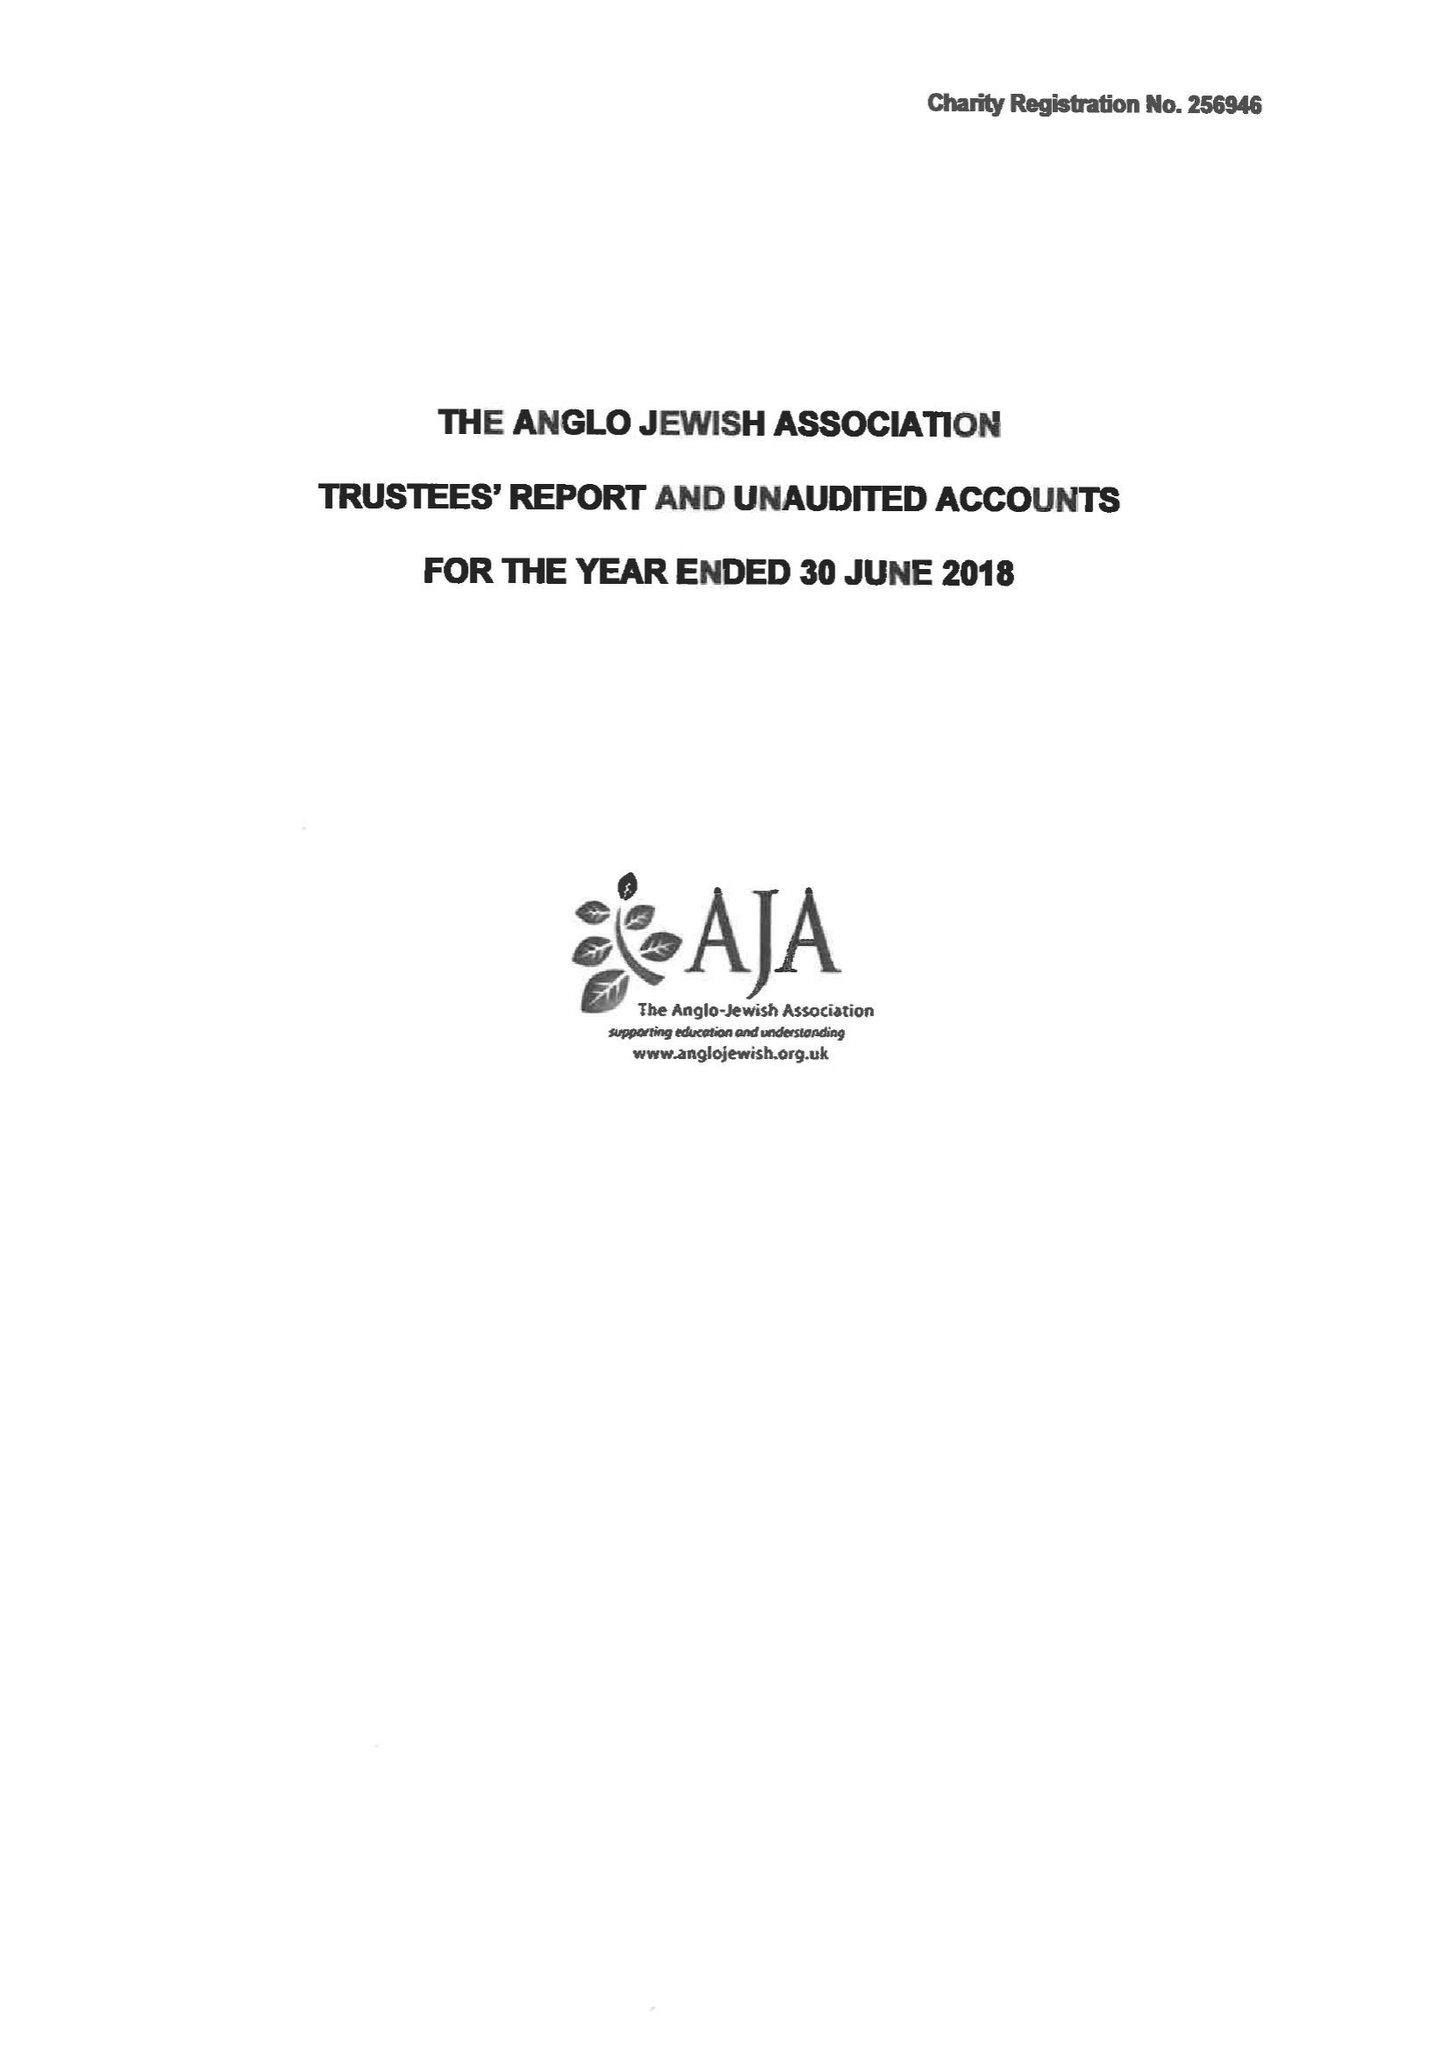What is the value for the charity_name?
Answer the question using a single word or phrase. The Anglo Jewish Association 